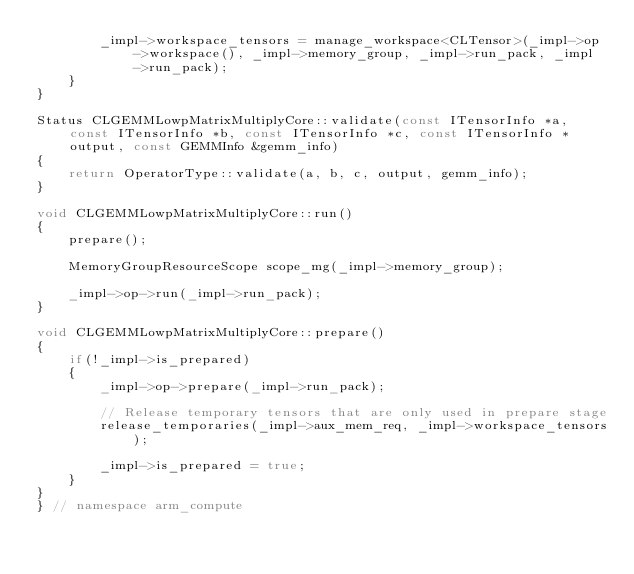Convert code to text. <code><loc_0><loc_0><loc_500><loc_500><_C++_>        _impl->workspace_tensors = manage_workspace<CLTensor>(_impl->op->workspace(), _impl->memory_group, _impl->run_pack, _impl->run_pack);
    }
}

Status CLGEMMLowpMatrixMultiplyCore::validate(const ITensorInfo *a, const ITensorInfo *b, const ITensorInfo *c, const ITensorInfo *output, const GEMMInfo &gemm_info)
{
    return OperatorType::validate(a, b, c, output, gemm_info);
}

void CLGEMMLowpMatrixMultiplyCore::run()
{
    prepare();

    MemoryGroupResourceScope scope_mg(_impl->memory_group);

    _impl->op->run(_impl->run_pack);
}

void CLGEMMLowpMatrixMultiplyCore::prepare()
{
    if(!_impl->is_prepared)
    {
        _impl->op->prepare(_impl->run_pack);

        // Release temporary tensors that are only used in prepare stage
        release_temporaries(_impl->aux_mem_req, _impl->workspace_tensors);

        _impl->is_prepared = true;
    }
}
} // namespace arm_compute
</code> 